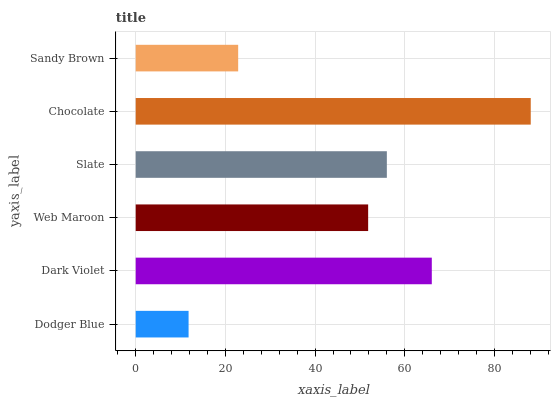Is Dodger Blue the minimum?
Answer yes or no. Yes. Is Chocolate the maximum?
Answer yes or no. Yes. Is Dark Violet the minimum?
Answer yes or no. No. Is Dark Violet the maximum?
Answer yes or no. No. Is Dark Violet greater than Dodger Blue?
Answer yes or no. Yes. Is Dodger Blue less than Dark Violet?
Answer yes or no. Yes. Is Dodger Blue greater than Dark Violet?
Answer yes or no. No. Is Dark Violet less than Dodger Blue?
Answer yes or no. No. Is Slate the high median?
Answer yes or no. Yes. Is Web Maroon the low median?
Answer yes or no. Yes. Is Dark Violet the high median?
Answer yes or no. No. Is Dark Violet the low median?
Answer yes or no. No. 